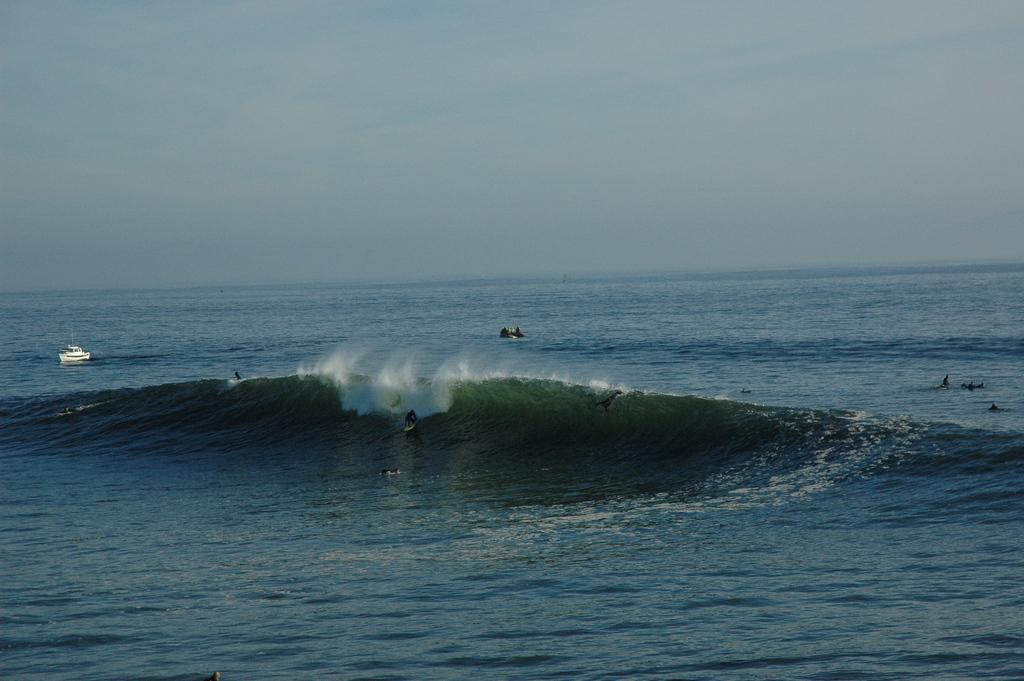What is the main feature of the image? The main feature of the image is water with waves. What are the people in the image doing? The people in the image are surfing on the waves. What other object is present on the water? There is a ship on the water. What is visible at the top of the image? The sky is visible at the top of the image. What type of pets can be seen playing with the waves in the image? There are no pets present in the image; it features people surfing on the waves. What drink is being served on the ship in the image? There is no indication of a drink being served on the ship in the image. 